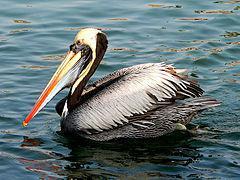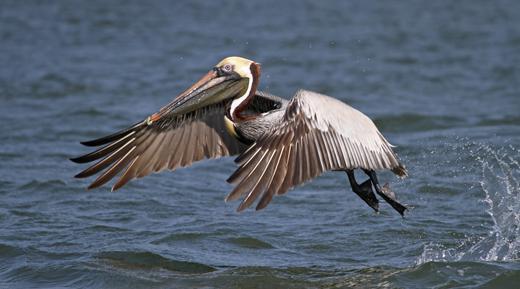The first image is the image on the left, the second image is the image on the right. For the images displayed, is the sentence "The bird in the right image is facing towards the left." factually correct? Answer yes or no. Yes. 